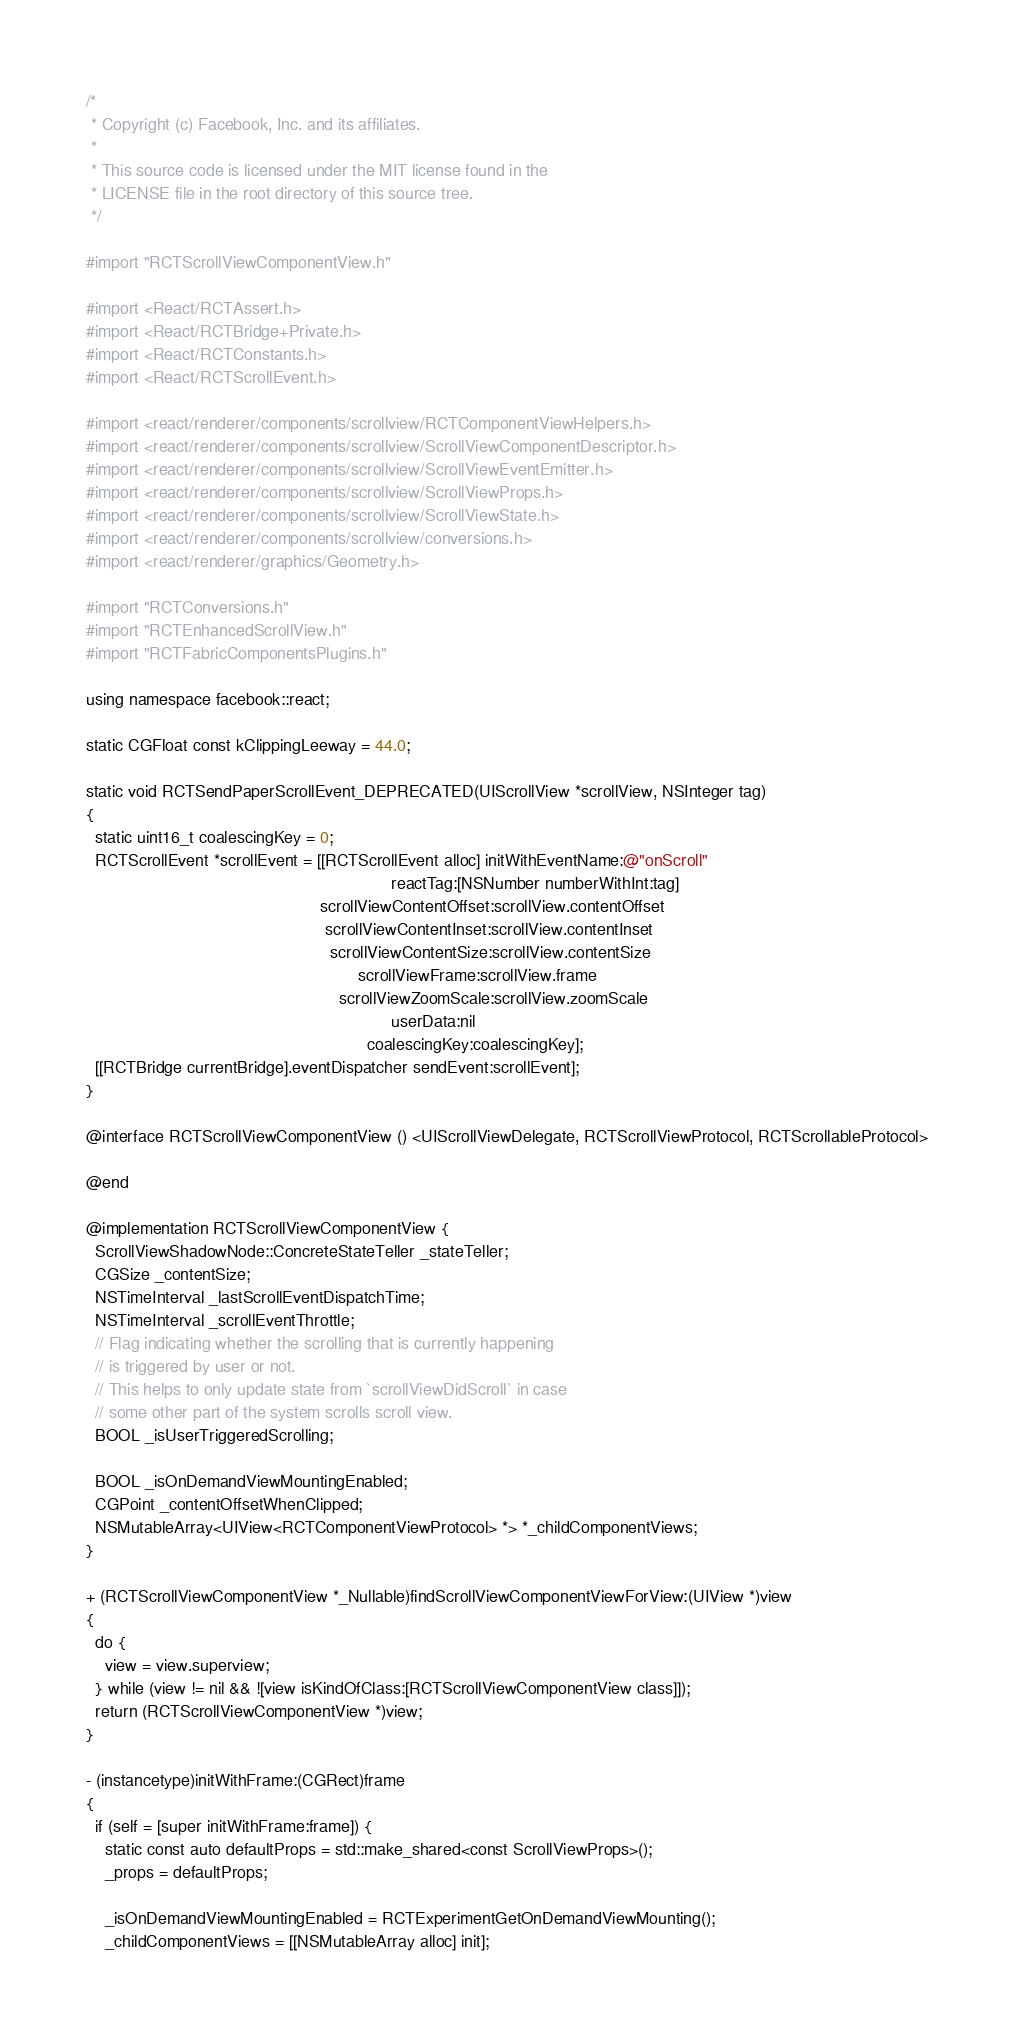<code> <loc_0><loc_0><loc_500><loc_500><_ObjectiveC_>/*
 * Copyright (c) Facebook, Inc. and its affiliates.
 *
 * This source code is licensed under the MIT license found in the
 * LICENSE file in the root directory of this source tree.
 */

#import "RCTScrollViewComponentView.h"

#import <React/RCTAssert.h>
#import <React/RCTBridge+Private.h>
#import <React/RCTConstants.h>
#import <React/RCTScrollEvent.h>

#import <react/renderer/components/scrollview/RCTComponentViewHelpers.h>
#import <react/renderer/components/scrollview/ScrollViewComponentDescriptor.h>
#import <react/renderer/components/scrollview/ScrollViewEventEmitter.h>
#import <react/renderer/components/scrollview/ScrollViewProps.h>
#import <react/renderer/components/scrollview/ScrollViewState.h>
#import <react/renderer/components/scrollview/conversions.h>
#import <react/renderer/graphics/Geometry.h>

#import "RCTConversions.h"
#import "RCTEnhancedScrollView.h"
#import "RCTFabricComponentsPlugins.h"

using namespace facebook::react;

static CGFloat const kClippingLeeway = 44.0;

static void RCTSendPaperScrollEvent_DEPRECATED(UIScrollView *scrollView, NSInteger tag)
{
  static uint16_t coalescingKey = 0;
  RCTScrollEvent *scrollEvent = [[RCTScrollEvent alloc] initWithEventName:@"onScroll"
                                                                 reactTag:[NSNumber numberWithInt:tag]
                                                  scrollViewContentOffset:scrollView.contentOffset
                                                   scrollViewContentInset:scrollView.contentInset
                                                    scrollViewContentSize:scrollView.contentSize
                                                          scrollViewFrame:scrollView.frame
                                                      scrollViewZoomScale:scrollView.zoomScale
                                                                 userData:nil
                                                            coalescingKey:coalescingKey];
  [[RCTBridge currentBridge].eventDispatcher sendEvent:scrollEvent];
}

@interface RCTScrollViewComponentView () <UIScrollViewDelegate, RCTScrollViewProtocol, RCTScrollableProtocol>

@end

@implementation RCTScrollViewComponentView {
  ScrollViewShadowNode::ConcreteStateTeller _stateTeller;
  CGSize _contentSize;
  NSTimeInterval _lastScrollEventDispatchTime;
  NSTimeInterval _scrollEventThrottle;
  // Flag indicating whether the scrolling that is currently happening
  // is triggered by user or not.
  // This helps to only update state from `scrollViewDidScroll` in case
  // some other part of the system scrolls scroll view.
  BOOL _isUserTriggeredScrolling;

  BOOL _isOnDemandViewMountingEnabled;
  CGPoint _contentOffsetWhenClipped;
  NSMutableArray<UIView<RCTComponentViewProtocol> *> *_childComponentViews;
}

+ (RCTScrollViewComponentView *_Nullable)findScrollViewComponentViewForView:(UIView *)view
{
  do {
    view = view.superview;
  } while (view != nil && ![view isKindOfClass:[RCTScrollViewComponentView class]]);
  return (RCTScrollViewComponentView *)view;
}

- (instancetype)initWithFrame:(CGRect)frame
{
  if (self = [super initWithFrame:frame]) {
    static const auto defaultProps = std::make_shared<const ScrollViewProps>();
    _props = defaultProps;

    _isOnDemandViewMountingEnabled = RCTExperimentGetOnDemandViewMounting();
    _childComponentViews = [[NSMutableArray alloc] init];
</code> 